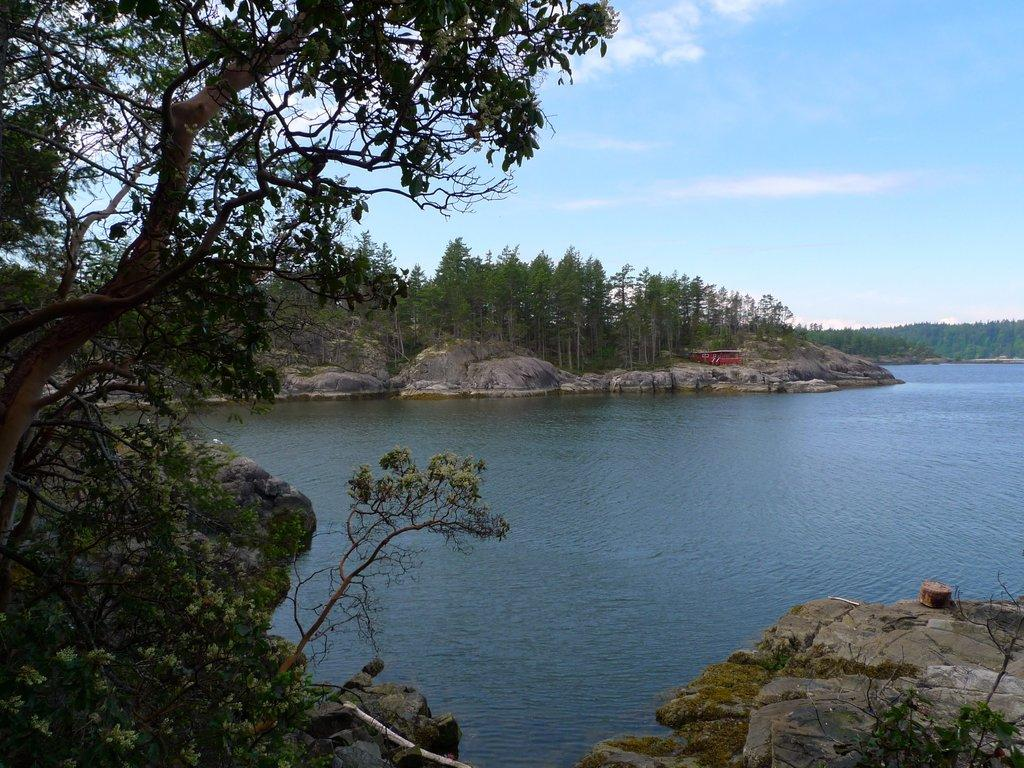What can be seen in the sky in the image? The sky with clouds is visible in the image. What type of vegetation is present in the image? There are trees in the image. What type of natural feature can be seen in the image? Rocks are present in the image. What body of water is visible in the image? There is a river in the image. How many experts are present in the image? There is no mention of experts in the image; it features natural elements such as the sky, clouds, trees, rocks, and river. 